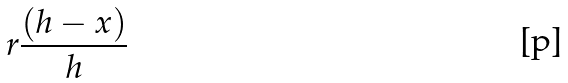Convert formula to latex. <formula><loc_0><loc_0><loc_500><loc_500>r \frac { ( h - x ) } { h }</formula> 